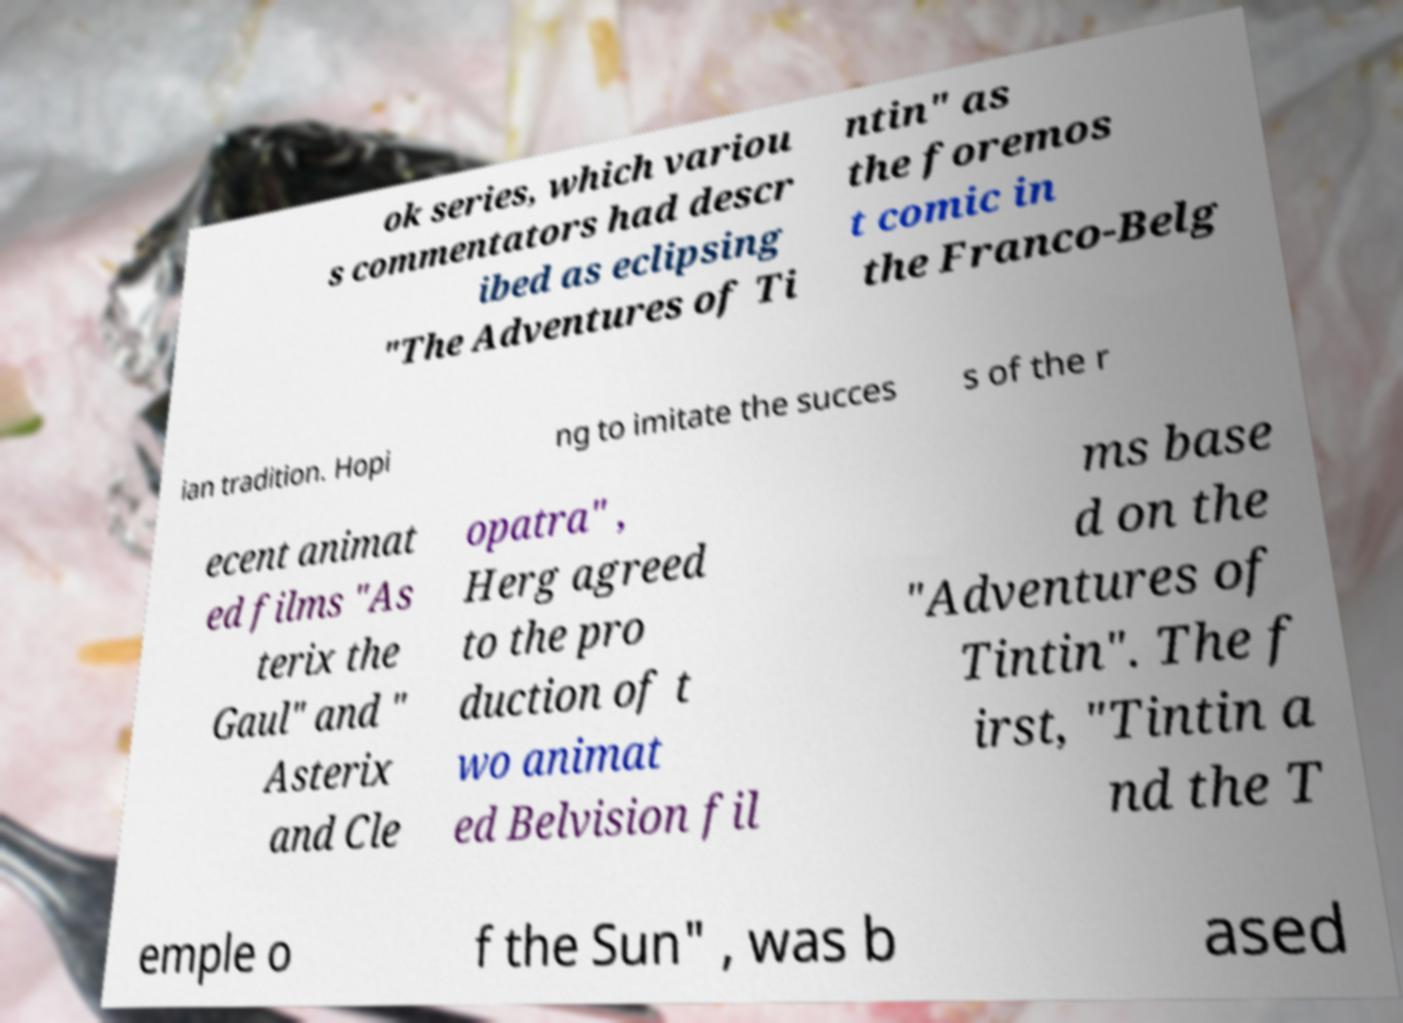Can you read and provide the text displayed in the image?This photo seems to have some interesting text. Can you extract and type it out for me? ok series, which variou s commentators had descr ibed as eclipsing "The Adventures of Ti ntin" as the foremos t comic in the Franco-Belg ian tradition. Hopi ng to imitate the succes s of the r ecent animat ed films "As terix the Gaul" and " Asterix and Cle opatra" , Herg agreed to the pro duction of t wo animat ed Belvision fil ms base d on the "Adventures of Tintin". The f irst, "Tintin a nd the T emple o f the Sun" , was b ased 